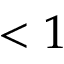Convert formula to latex. <formula><loc_0><loc_0><loc_500><loc_500>< 1</formula> 